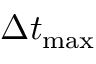Convert formula to latex. <formula><loc_0><loc_0><loc_500><loc_500>\Delta t _ { \max }</formula> 